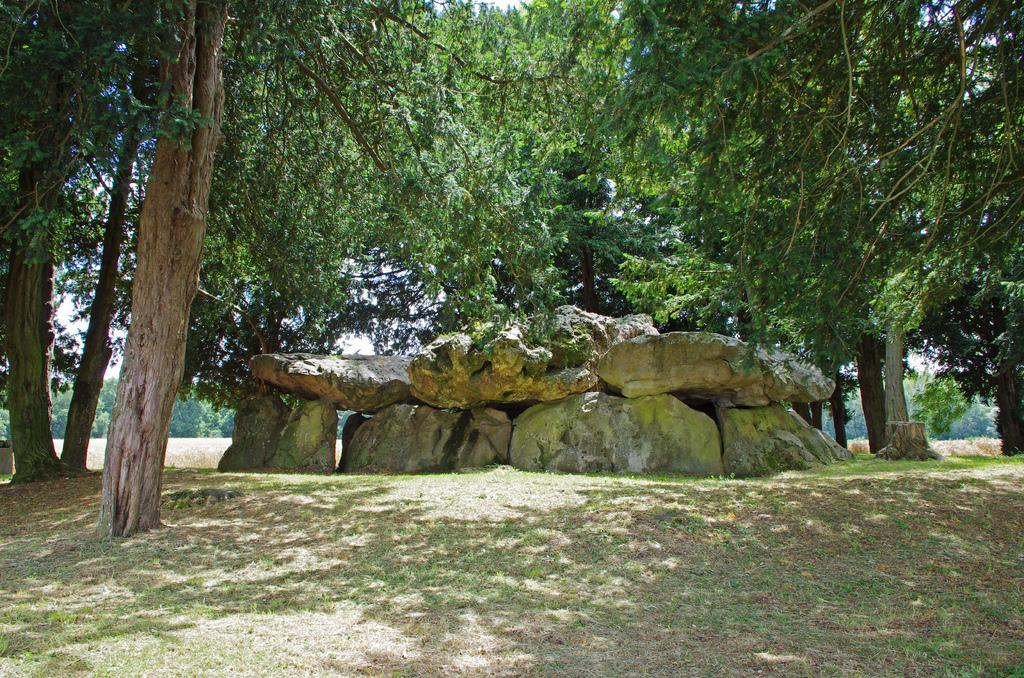What is located in the middle of the image? There are rocks in the middle of the image. What type of vegetation can be seen in the image? There are trees in the image. What is covering the ground in the image? There is grass on the ground in the image. What is visible in the background of the image? The sky is visible in the image. What type of lawyer is standing near the cemetery in the image? There is no lawyer or cemetery present in the image; it features rocks, trees, grass, and the sky. 